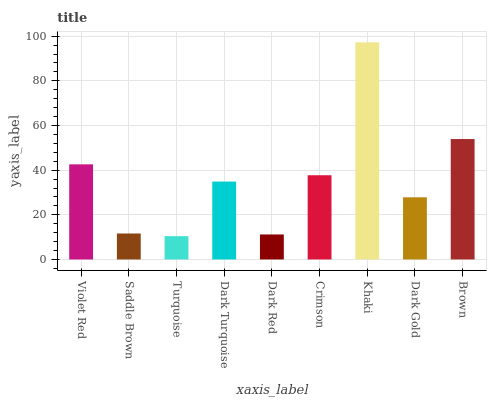Is Turquoise the minimum?
Answer yes or no. Yes. Is Khaki the maximum?
Answer yes or no. Yes. Is Saddle Brown the minimum?
Answer yes or no. No. Is Saddle Brown the maximum?
Answer yes or no. No. Is Violet Red greater than Saddle Brown?
Answer yes or no. Yes. Is Saddle Brown less than Violet Red?
Answer yes or no. Yes. Is Saddle Brown greater than Violet Red?
Answer yes or no. No. Is Violet Red less than Saddle Brown?
Answer yes or no. No. Is Dark Turquoise the high median?
Answer yes or no. Yes. Is Dark Turquoise the low median?
Answer yes or no. Yes. Is Khaki the high median?
Answer yes or no. No. Is Dark Gold the low median?
Answer yes or no. No. 